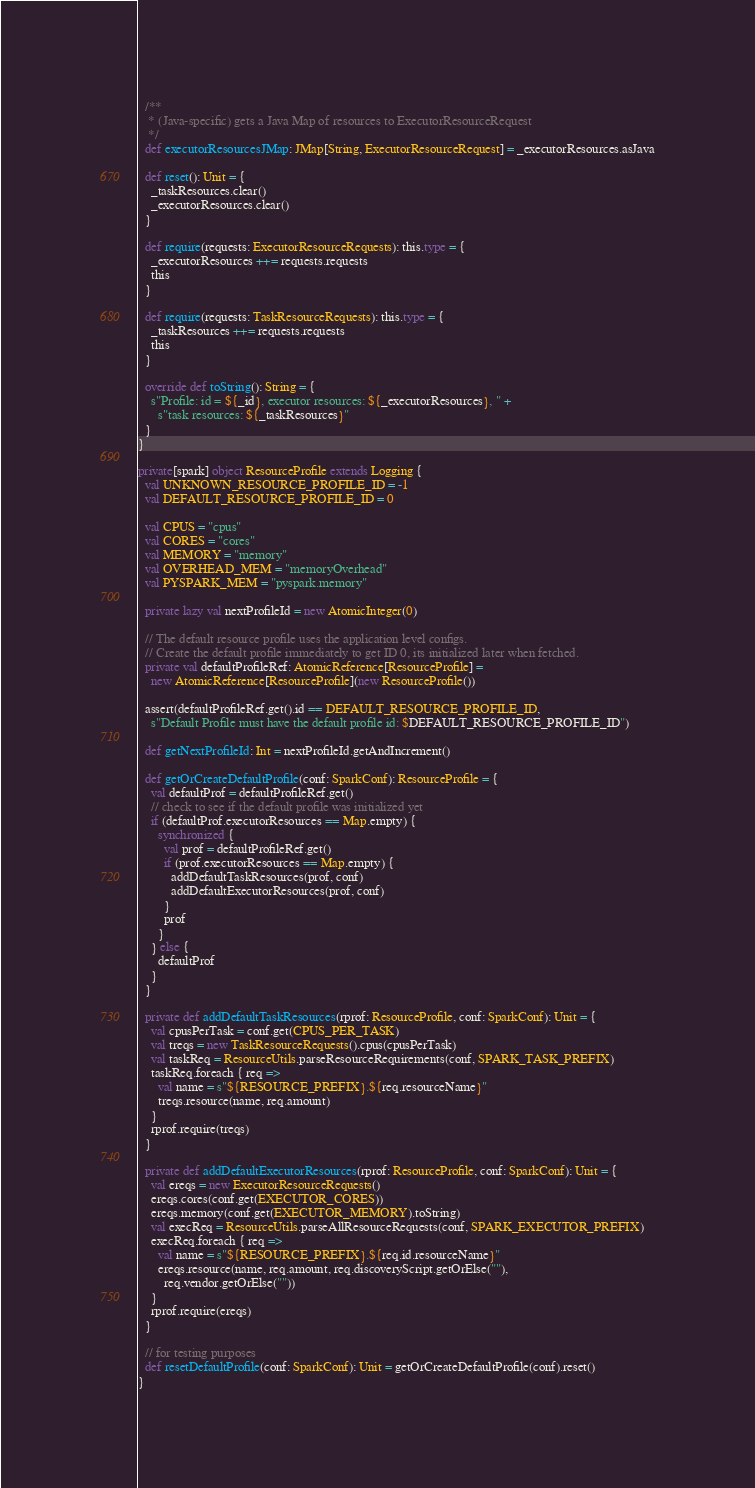Convert code to text. <code><loc_0><loc_0><loc_500><loc_500><_Scala_>
  /**
   * (Java-specific) gets a Java Map of resources to ExecutorResourceRequest
   */
  def executorResourcesJMap: JMap[String, ExecutorResourceRequest] = _executorResources.asJava

  def reset(): Unit = {
    _taskResources.clear()
    _executorResources.clear()
  }

  def require(requests: ExecutorResourceRequests): this.type = {
    _executorResources ++= requests.requests
    this
  }

  def require(requests: TaskResourceRequests): this.type = {
    _taskResources ++= requests.requests
    this
  }

  override def toString(): String = {
    s"Profile: id = ${_id}, executor resources: ${_executorResources}, " +
      s"task resources: ${_taskResources}"
  }
}

private[spark] object ResourceProfile extends Logging {
  val UNKNOWN_RESOURCE_PROFILE_ID = -1
  val DEFAULT_RESOURCE_PROFILE_ID = 0

  val CPUS = "cpus"
  val CORES = "cores"
  val MEMORY = "memory"
  val OVERHEAD_MEM = "memoryOverhead"
  val PYSPARK_MEM = "pyspark.memory"

  private lazy val nextProfileId = new AtomicInteger(0)

  // The default resource profile uses the application level configs.
  // Create the default profile immediately to get ID 0, its initialized later when fetched.
  private val defaultProfileRef: AtomicReference[ResourceProfile] =
    new AtomicReference[ResourceProfile](new ResourceProfile())

  assert(defaultProfileRef.get().id == DEFAULT_RESOURCE_PROFILE_ID,
    s"Default Profile must have the default profile id: $DEFAULT_RESOURCE_PROFILE_ID")

  def getNextProfileId: Int = nextProfileId.getAndIncrement()

  def getOrCreateDefaultProfile(conf: SparkConf): ResourceProfile = {
    val defaultProf = defaultProfileRef.get()
    // check to see if the default profile was initialized yet
    if (defaultProf.executorResources == Map.empty) {
      synchronized {
        val prof = defaultProfileRef.get()
        if (prof.executorResources == Map.empty) {
          addDefaultTaskResources(prof, conf)
          addDefaultExecutorResources(prof, conf)
        }
        prof
      }
    } else {
      defaultProf
    }
  }

  private def addDefaultTaskResources(rprof: ResourceProfile, conf: SparkConf): Unit = {
    val cpusPerTask = conf.get(CPUS_PER_TASK)
    val treqs = new TaskResourceRequests().cpus(cpusPerTask)
    val taskReq = ResourceUtils.parseResourceRequirements(conf, SPARK_TASK_PREFIX)
    taskReq.foreach { req =>
      val name = s"${RESOURCE_PREFIX}.${req.resourceName}"
      treqs.resource(name, req.amount)
    }
    rprof.require(treqs)
  }

  private def addDefaultExecutorResources(rprof: ResourceProfile, conf: SparkConf): Unit = {
    val ereqs = new ExecutorResourceRequests()
    ereqs.cores(conf.get(EXECUTOR_CORES))
    ereqs.memory(conf.get(EXECUTOR_MEMORY).toString)
    val execReq = ResourceUtils.parseAllResourceRequests(conf, SPARK_EXECUTOR_PREFIX)
    execReq.foreach { req =>
      val name = s"${RESOURCE_PREFIX}.${req.id.resourceName}"
      ereqs.resource(name, req.amount, req.discoveryScript.getOrElse(""),
        req.vendor.getOrElse(""))
    }
    rprof.require(ereqs)
  }

  // for testing purposes
  def resetDefaultProfile(conf: SparkConf): Unit = getOrCreateDefaultProfile(conf).reset()
}
</code> 